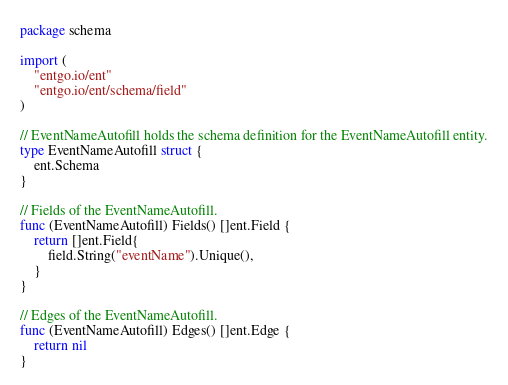<code> <loc_0><loc_0><loc_500><loc_500><_Go_>package schema

import (
	"entgo.io/ent"
	"entgo.io/ent/schema/field"
)

// EventNameAutofill holds the schema definition for the EventNameAutofill entity.
type EventNameAutofill struct {
	ent.Schema
}

// Fields of the EventNameAutofill.
func (EventNameAutofill) Fields() []ent.Field {
	return []ent.Field{
		field.String("eventName").Unique(),
	}
}

// Edges of the EventNameAutofill.
func (EventNameAutofill) Edges() []ent.Edge {
	return nil
}
</code> 